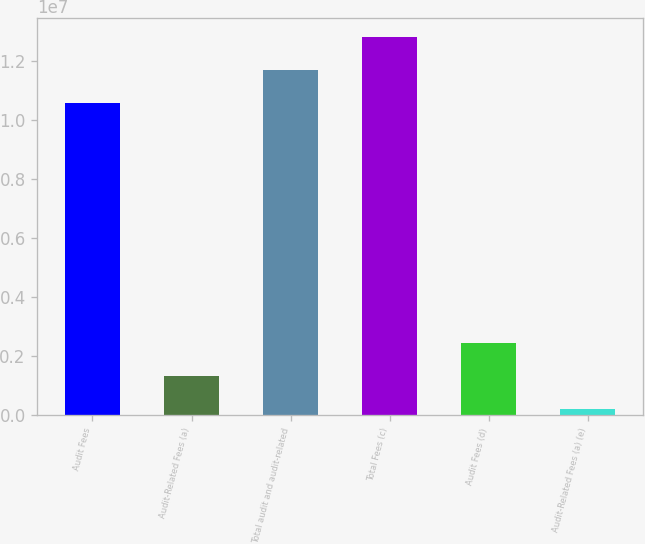Convert chart to OTSL. <chart><loc_0><loc_0><loc_500><loc_500><bar_chart><fcel>Audit Fees<fcel>Audit-Related Fees (a)<fcel>Total audit and audit-related<fcel>Total Fees (c)<fcel>Audit Fees (d)<fcel>Audit-Related Fees (a) (e)<nl><fcel>1.05872e+07<fcel>1.31658e+06<fcel>1.17037e+07<fcel>1.28203e+07<fcel>2.43317e+06<fcel>200000<nl></chart> 